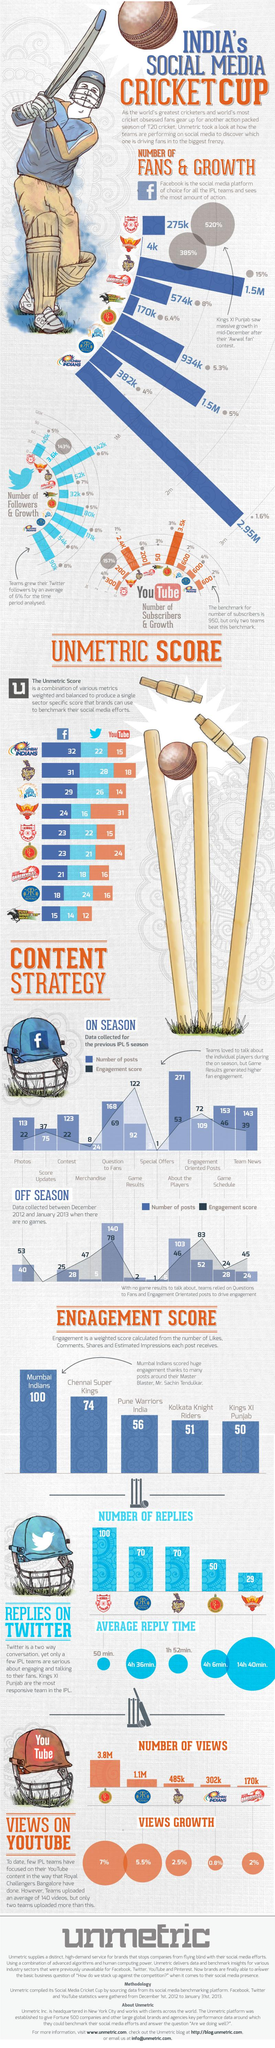Mention a couple of crucial points in this snapshot. The average reply time for Knight Riders is approximately 1 hour and 52 minutes. Of the contents, how many have an engagement score greater than 100? Of the teams, only two have an engagement score that exceeds 70. The Delhi Daredevils have the least number of YouTube views compared to other teams. The Unmetric score of Mumbai Indians is 69. 